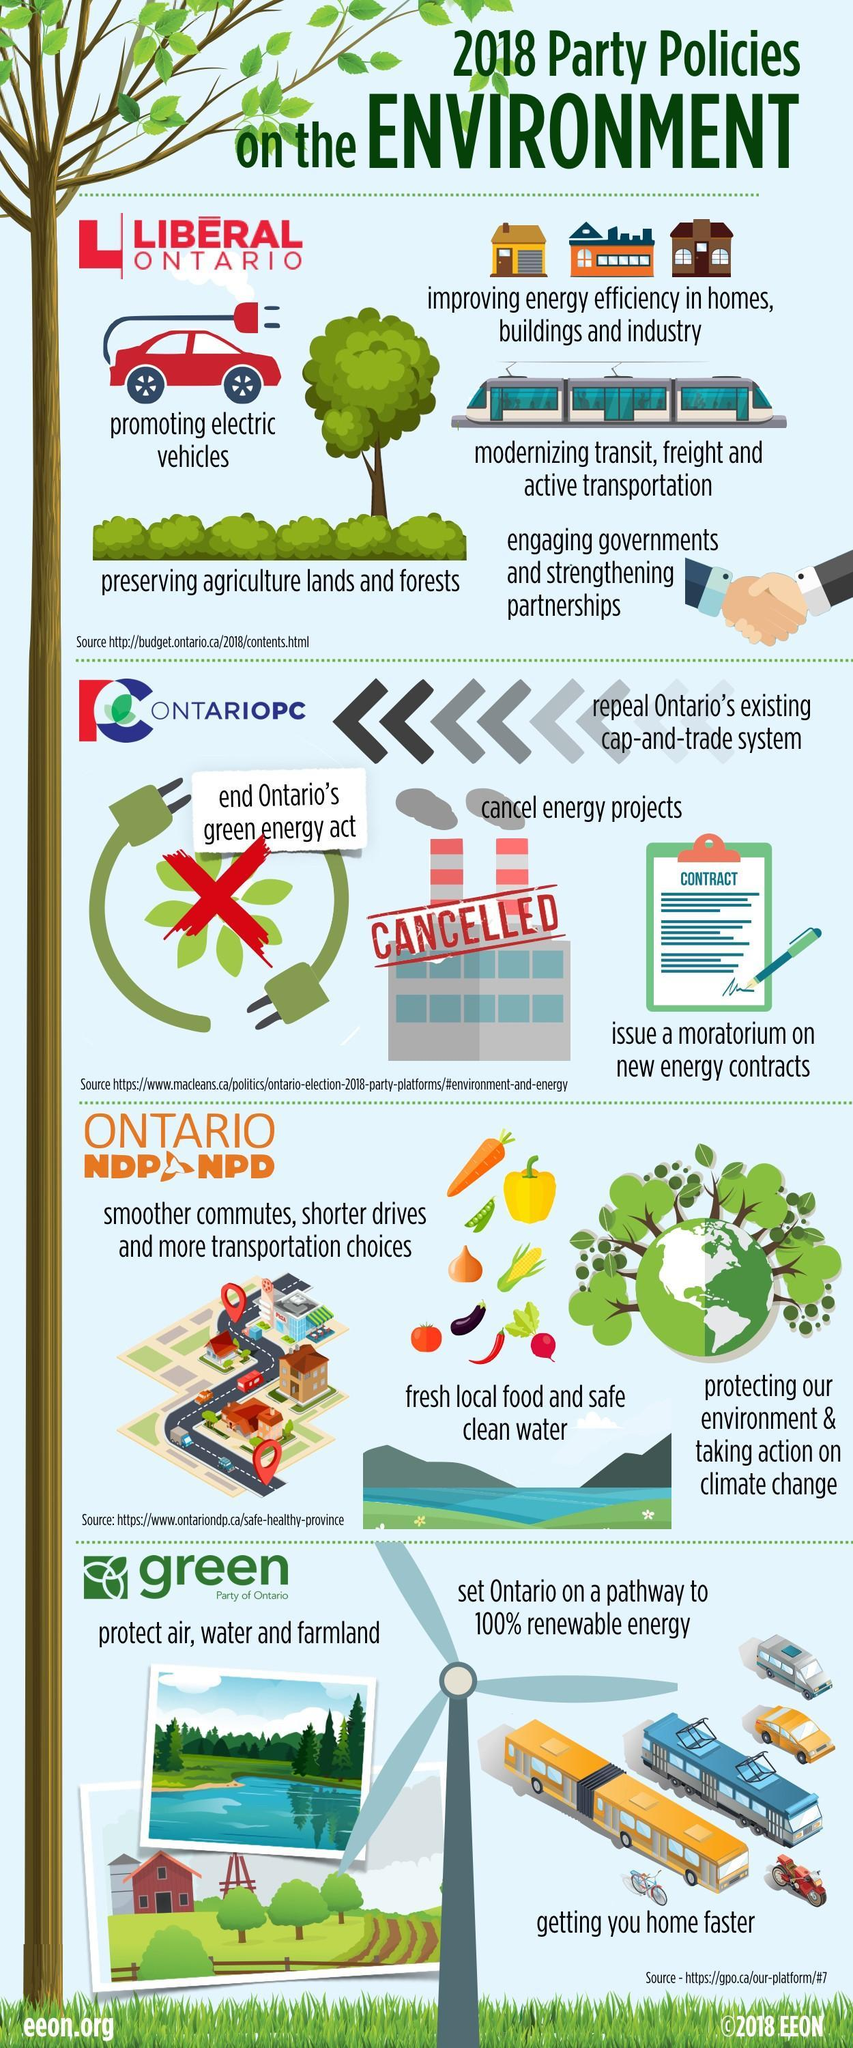Which aspects of Ontario's carbon reduction efforts were annulled?
Answer the question with a short phrase. green energy act, energy projects 